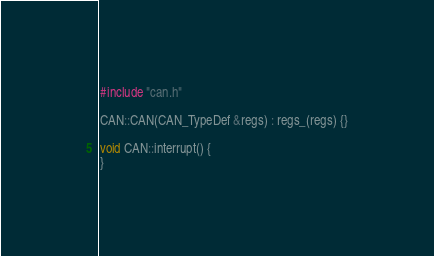<code> <loc_0><loc_0><loc_500><loc_500><_C++_>#include "can.h"

CAN::CAN(CAN_TypeDef &regs) : regs_(regs) {}

void CAN::interrupt() {
}</code> 